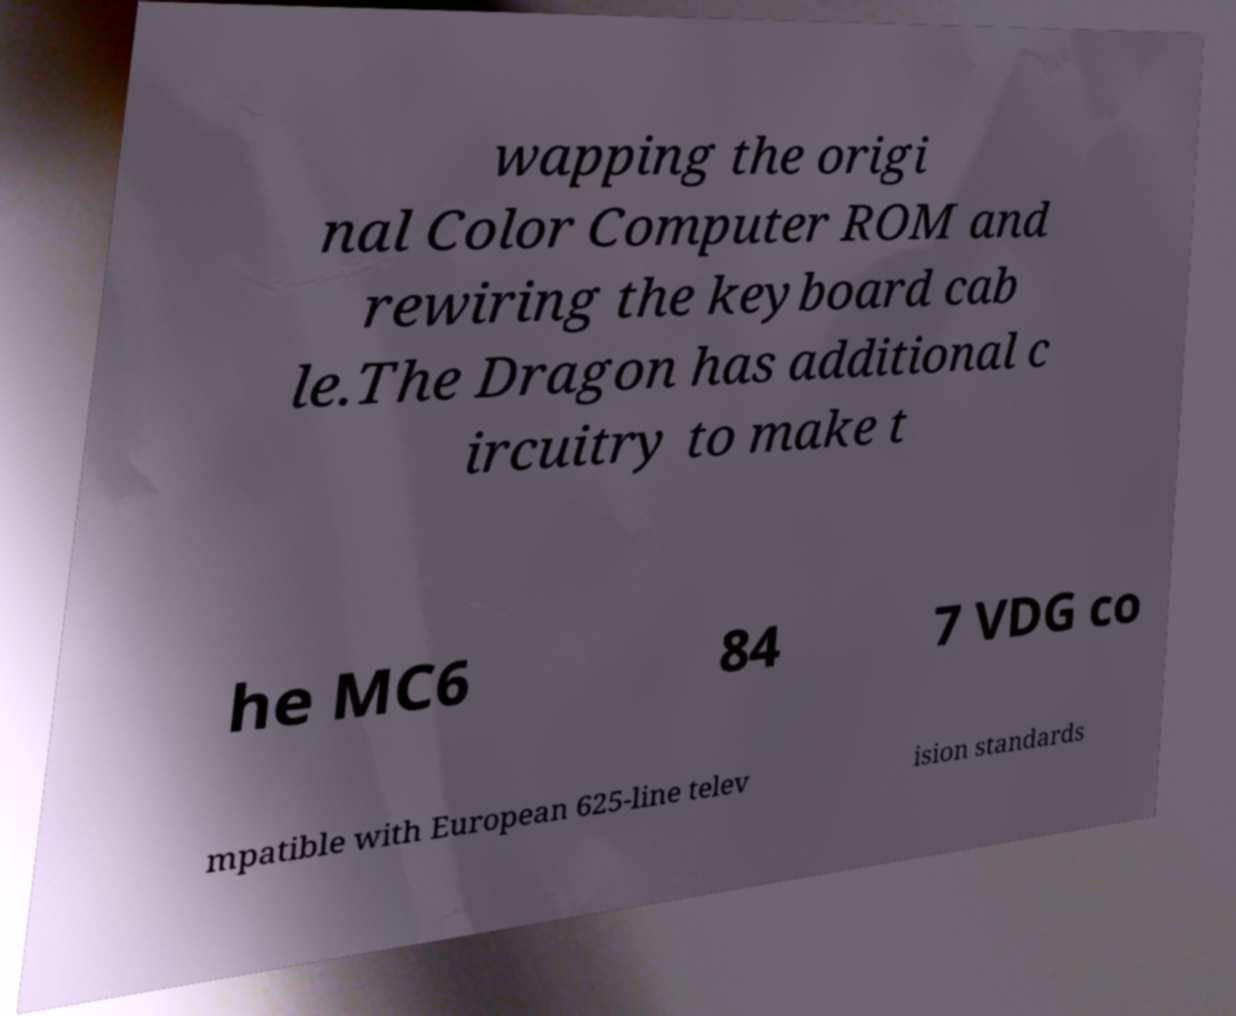What messages or text are displayed in this image? I need them in a readable, typed format. wapping the origi nal Color Computer ROM and rewiring the keyboard cab le.The Dragon has additional c ircuitry to make t he MC6 84 7 VDG co mpatible with European 625-line telev ision standards 